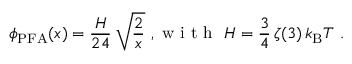Convert formula to latex. <formula><loc_0><loc_0><loc_500><loc_500>\phi _ { P F A } ( x ) = \frac { H } { 2 4 } \, \sqrt { \frac { 2 } { x } } , w i t h H = \frac { 3 } { 4 } \, \zeta ( 3 ) \, k _ { B } T .</formula> 